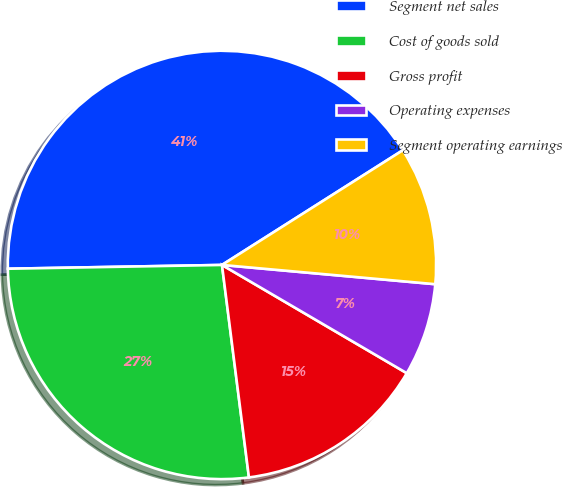Convert chart to OTSL. <chart><loc_0><loc_0><loc_500><loc_500><pie_chart><fcel>Segment net sales<fcel>Cost of goods sold<fcel>Gross profit<fcel>Operating expenses<fcel>Segment operating earnings<nl><fcel>41.29%<fcel>26.73%<fcel>14.56%<fcel>7.0%<fcel>10.43%<nl></chart> 